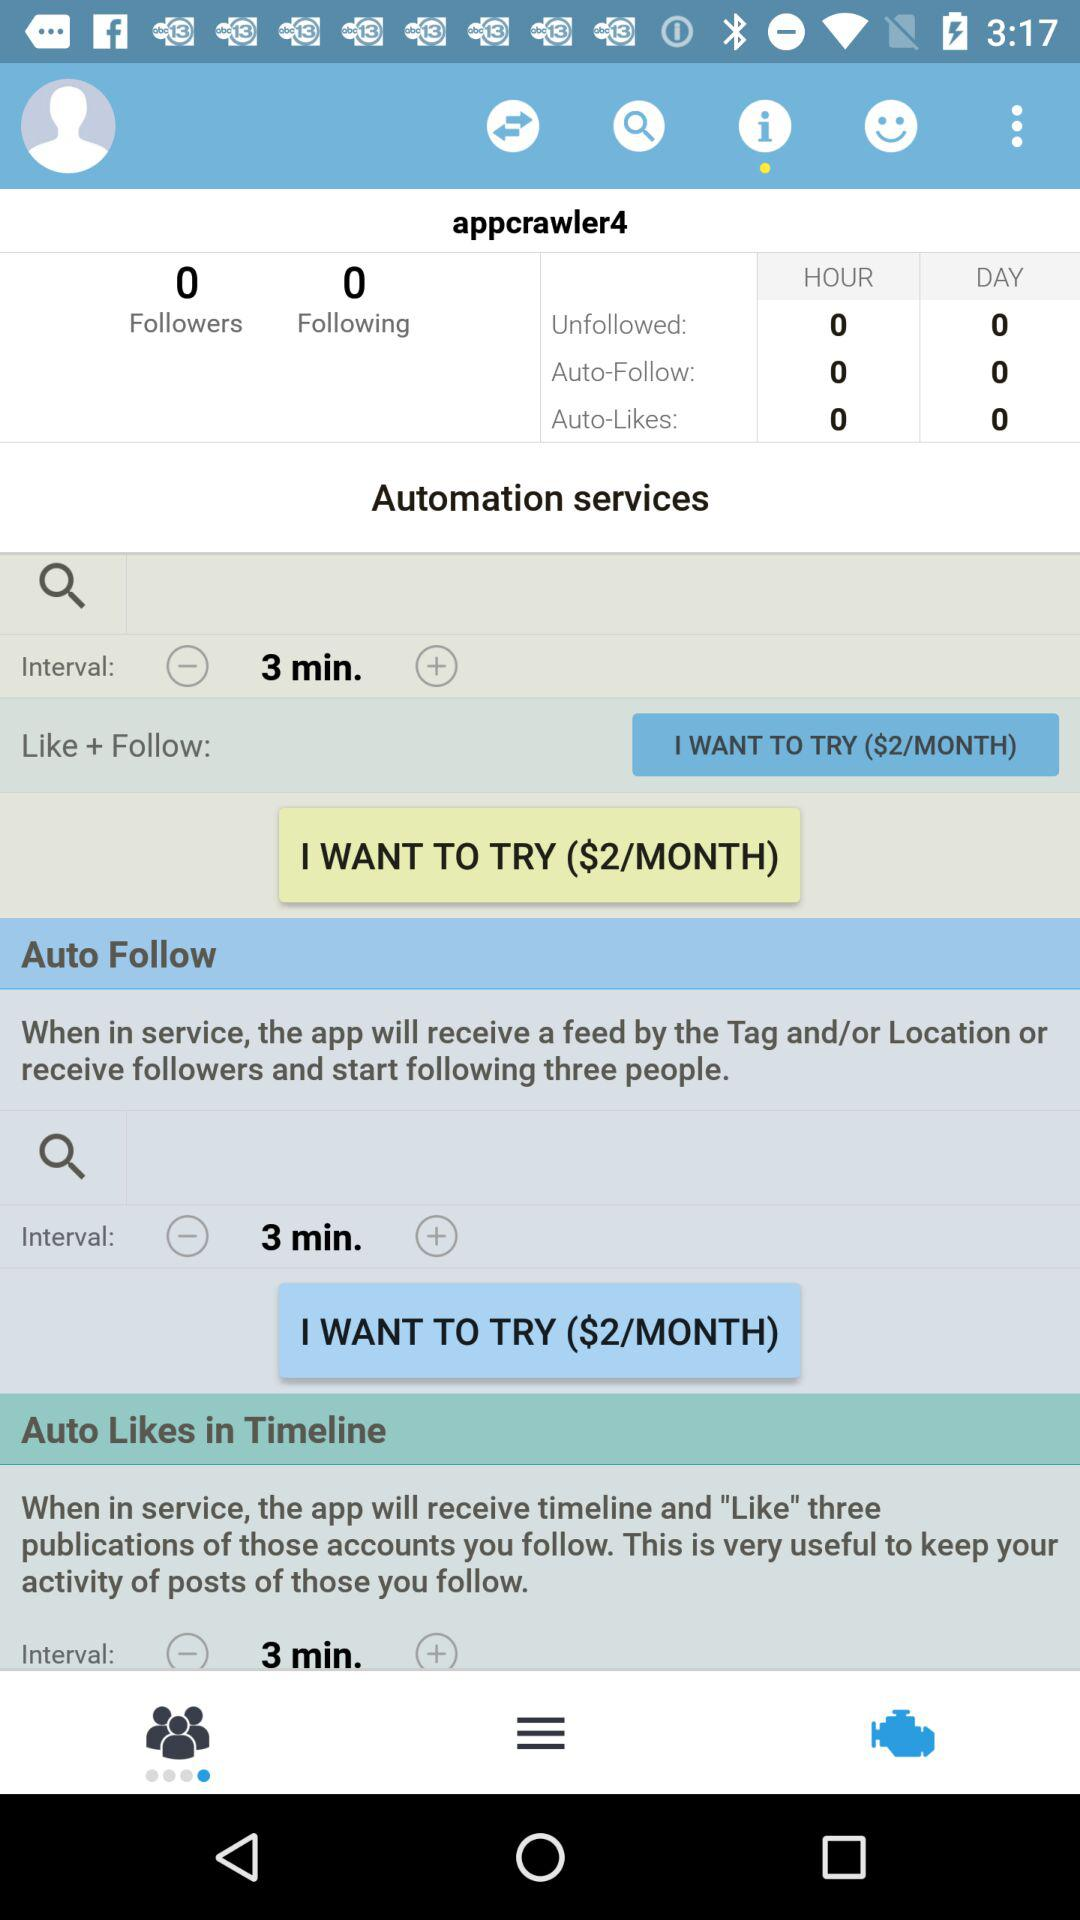How many people unfollowed in an hour? The number of people who unfollowed in an hour is 0. 